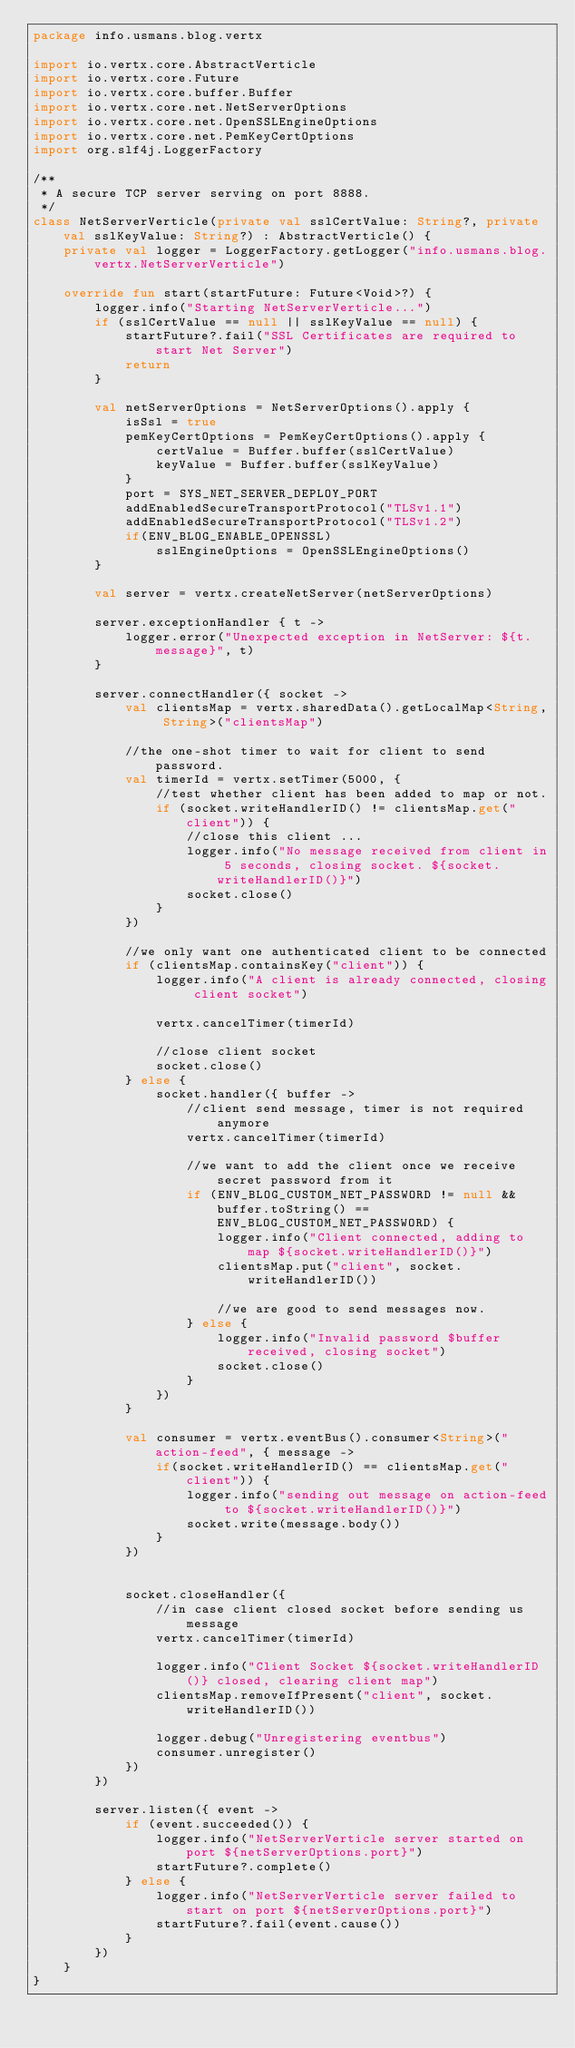<code> <loc_0><loc_0><loc_500><loc_500><_Kotlin_>package info.usmans.blog.vertx

import io.vertx.core.AbstractVerticle
import io.vertx.core.Future
import io.vertx.core.buffer.Buffer
import io.vertx.core.net.NetServerOptions
import io.vertx.core.net.OpenSSLEngineOptions
import io.vertx.core.net.PemKeyCertOptions
import org.slf4j.LoggerFactory

/**
 * A secure TCP server serving on port 8888.
 */
class NetServerVerticle(private val sslCertValue: String?, private val sslKeyValue: String?) : AbstractVerticle() {
    private val logger = LoggerFactory.getLogger("info.usmans.blog.vertx.NetServerVerticle")

    override fun start(startFuture: Future<Void>?) {
        logger.info("Starting NetServerVerticle...")
        if (sslCertValue == null || sslKeyValue == null) {
            startFuture?.fail("SSL Certificates are required to start Net Server")
            return
        }

        val netServerOptions = NetServerOptions().apply {
            isSsl = true
            pemKeyCertOptions = PemKeyCertOptions().apply {
                certValue = Buffer.buffer(sslCertValue)
                keyValue = Buffer.buffer(sslKeyValue)
            }
            port = SYS_NET_SERVER_DEPLOY_PORT
            addEnabledSecureTransportProtocol("TLSv1.1")
            addEnabledSecureTransportProtocol("TLSv1.2")
            if(ENV_BLOG_ENABLE_OPENSSL)
                sslEngineOptions = OpenSSLEngineOptions()
        }

        val server = vertx.createNetServer(netServerOptions)

        server.exceptionHandler { t ->
            logger.error("Unexpected exception in NetServer: ${t.message}", t)
        }

        server.connectHandler({ socket ->
            val clientsMap = vertx.sharedData().getLocalMap<String, String>("clientsMap")

            //the one-shot timer to wait for client to send password.
            val timerId = vertx.setTimer(5000, {
                //test whether client has been added to map or not.
                if (socket.writeHandlerID() != clientsMap.get("client")) {
                    //close this client ...
                    logger.info("No message received from client in 5 seconds, closing socket. ${socket.writeHandlerID()}")
                    socket.close()
                }
            })

            //we only want one authenticated client to be connected
            if (clientsMap.containsKey("client")) {
                logger.info("A client is already connected, closing client socket")

                vertx.cancelTimer(timerId)

                //close client socket
                socket.close()
            } else {
                socket.handler({ buffer ->
                    //client send message, timer is not required anymore
                    vertx.cancelTimer(timerId)

                    //we want to add the client once we receive secret password from it
                    if (ENV_BLOG_CUSTOM_NET_PASSWORD != null && buffer.toString() == ENV_BLOG_CUSTOM_NET_PASSWORD) {
                        logger.info("Client connected, adding to map ${socket.writeHandlerID()}")
                        clientsMap.put("client", socket.writeHandlerID())

                        //we are good to send messages now.
                    } else {
                        logger.info("Invalid password $buffer received, closing socket")
                        socket.close()
                    }
                })
            }

            val consumer = vertx.eventBus().consumer<String>("action-feed", { message ->
                if(socket.writeHandlerID() == clientsMap.get("client")) {
                    logger.info("sending out message on action-feed to ${socket.writeHandlerID()}")
                    socket.write(message.body())
                }
            })


            socket.closeHandler({
                //in case client closed socket before sending us message
                vertx.cancelTimer(timerId)

                logger.info("Client Socket ${socket.writeHandlerID()} closed, clearing client map")
                clientsMap.removeIfPresent("client", socket.writeHandlerID())

                logger.debug("Unregistering eventbus")
                consumer.unregister()
            })
        })

        server.listen({ event ->
            if (event.succeeded()) {
                logger.info("NetServerVerticle server started on port ${netServerOptions.port}")
                startFuture?.complete()
            } else {
                logger.info("NetServerVerticle server failed to start on port ${netServerOptions.port}")
                startFuture?.fail(event.cause())
            }
        })
    }
}</code> 